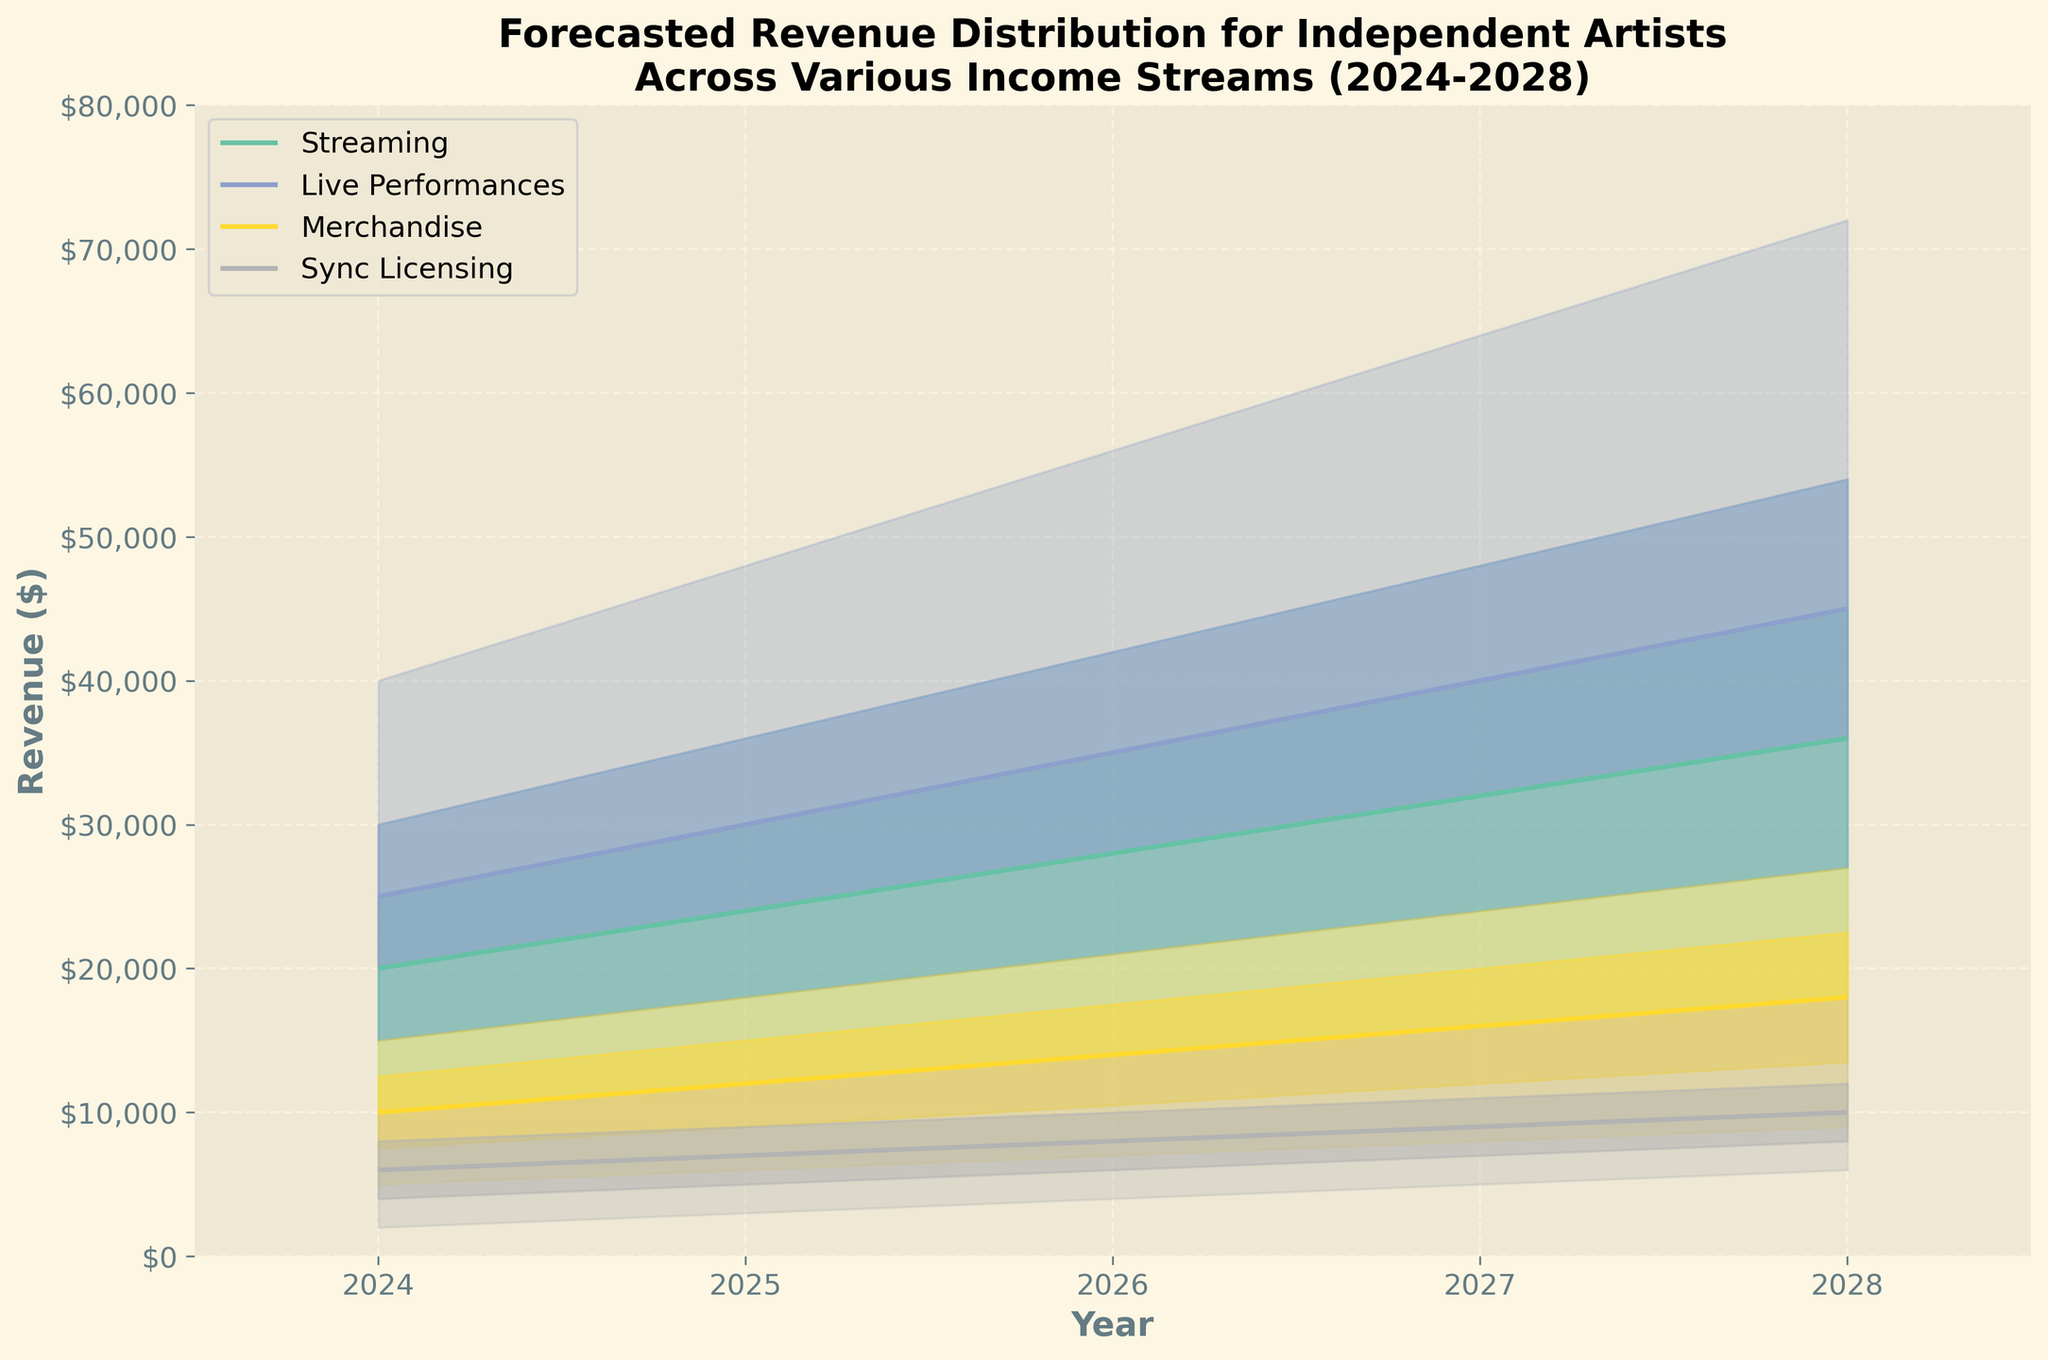What are the income streams represented in the figure? The figure shows various income streams with distinct colors, indicating the different categories.
Answer: Streaming, Live Performances, Merchandise, Sync Licensing What is the highest median revenue for Live Performances in 2028? To find the highest median revenue for Live Performances in 2028, locate the "Live Performances" income stream and follow it to the year 2028. Check the median value.
Answer: $45,000 How does median revenue from Streaming change from 2024 to 2028? Locate the "Streaming" income stream in the median revenue line and track its value from 2024 to 2028. Note the changes at these two points.
Answer: Increases from $20,000 to $36,000 What is the range of forecasted revenue for Merchandise in 2026? Identify the "Merchandise" income stream for the year 2026 and determine the lower and upper bounds of the forecasted revenue.
Answer: $7,000 to $21,000 Which income stream has the highest upper bound in 2027? Compare the upper bounds of all income streams in the year 2027 and identify which stream has the highest value.
Answer: Live Performances Between which years does Sync Licensing show the highest rate of increase in the median value? Track the median values of Sync Licensing from year to year and find the period with the highest increase.
Answer: 2024 to 2025 What is the lower middle forecasted revenue for Streaming in 2025? Locate the Streaming income stream for the year 2025 and check the lower middle value.
Answer: $18,000 Compare the upper bound revenue for Live Performances in 2026 and 2028. Which year is higher? Identify and compare the upper bounds for Live Performances in 2026 and 2028. Determine which year has the higher value.
Answer: 2028 What is the title of the figure? The title of the figure is displayed at the top, indicating what the chart represents.
Answer: Forecasted Revenue Distribution for Independent Artists Across Various Income Streams (2024-2028) How much does the median revenue for Merchandise increase from 2024 to 2028? Find the median revenue of Merchandise for 2024 and 2028, then compute the difference between these two values.
Answer: $8,000 